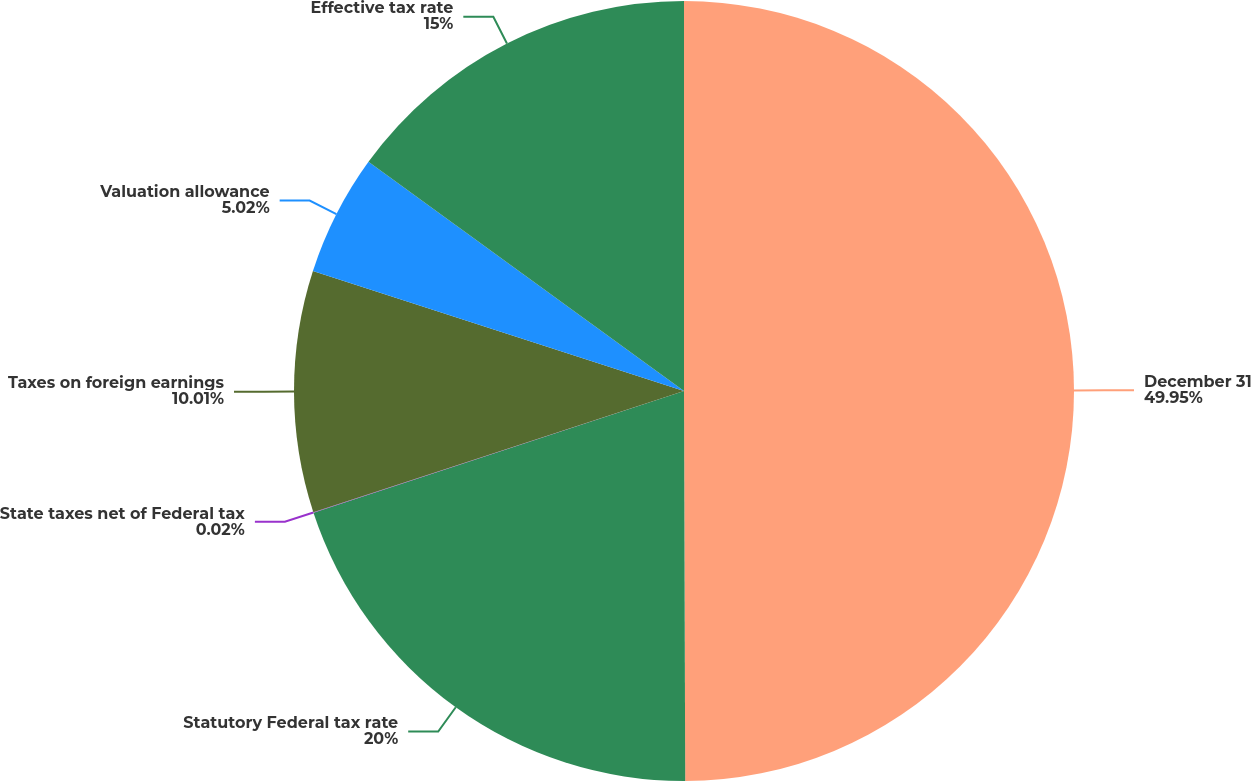Convert chart. <chart><loc_0><loc_0><loc_500><loc_500><pie_chart><fcel>December 31<fcel>Statutory Federal tax rate<fcel>State taxes net of Federal tax<fcel>Taxes on foreign earnings<fcel>Valuation allowance<fcel>Effective tax rate<nl><fcel>49.95%<fcel>20.0%<fcel>0.02%<fcel>10.01%<fcel>5.02%<fcel>15.0%<nl></chart> 